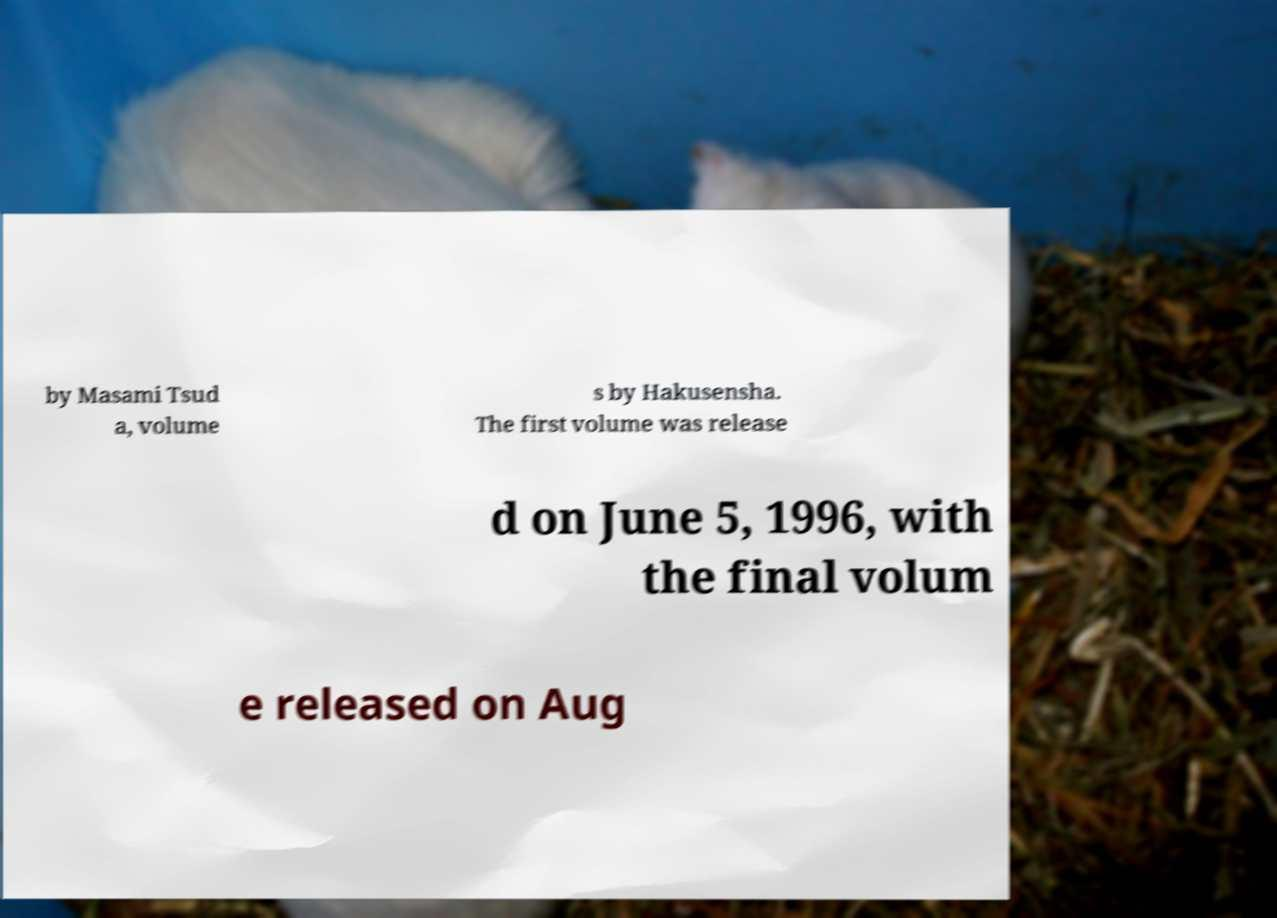Can you accurately transcribe the text from the provided image for me? by Masami Tsud a, volume s by Hakusensha. The first volume was release d on June 5, 1996, with the final volum e released on Aug 